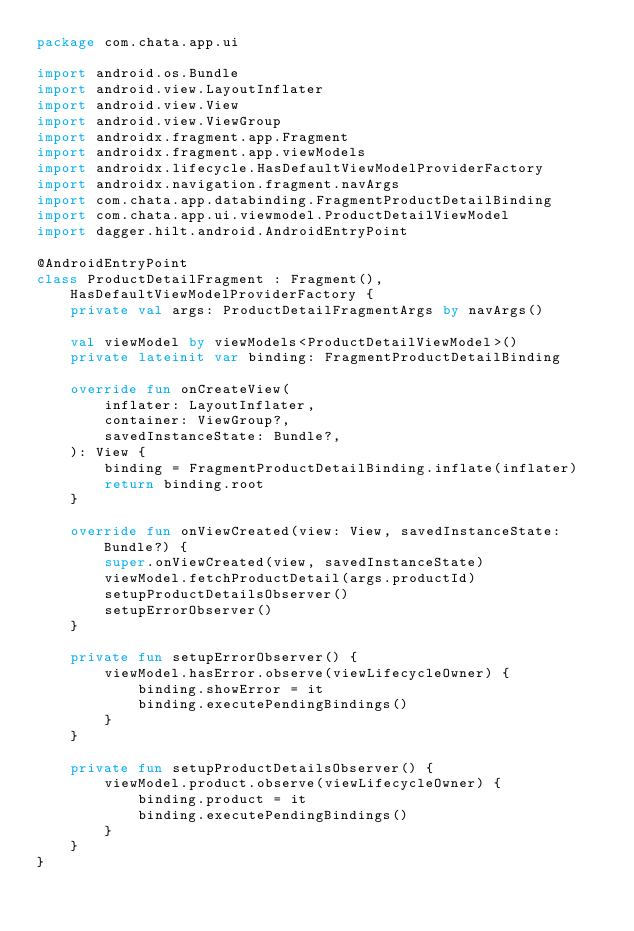Convert code to text. <code><loc_0><loc_0><loc_500><loc_500><_Kotlin_>package com.chata.app.ui

import android.os.Bundle
import android.view.LayoutInflater
import android.view.View
import android.view.ViewGroup
import androidx.fragment.app.Fragment
import androidx.fragment.app.viewModels
import androidx.lifecycle.HasDefaultViewModelProviderFactory
import androidx.navigation.fragment.navArgs
import com.chata.app.databinding.FragmentProductDetailBinding
import com.chata.app.ui.viewmodel.ProductDetailViewModel
import dagger.hilt.android.AndroidEntryPoint

@AndroidEntryPoint
class ProductDetailFragment : Fragment(), HasDefaultViewModelProviderFactory {
    private val args: ProductDetailFragmentArgs by navArgs()

    val viewModel by viewModels<ProductDetailViewModel>()
    private lateinit var binding: FragmentProductDetailBinding

    override fun onCreateView(
        inflater: LayoutInflater,
        container: ViewGroup?,
        savedInstanceState: Bundle?,
    ): View {
        binding = FragmentProductDetailBinding.inflate(inflater)
        return binding.root
    }

    override fun onViewCreated(view: View, savedInstanceState: Bundle?) {
        super.onViewCreated(view, savedInstanceState)
        viewModel.fetchProductDetail(args.productId)
        setupProductDetailsObserver()
        setupErrorObserver()
    }

    private fun setupErrorObserver() {
        viewModel.hasError.observe(viewLifecycleOwner) {
            binding.showError = it
            binding.executePendingBindings()
        }
    }

    private fun setupProductDetailsObserver() {
        viewModel.product.observe(viewLifecycleOwner) {
            binding.product = it
            binding.executePendingBindings()
        }
    }
}
</code> 